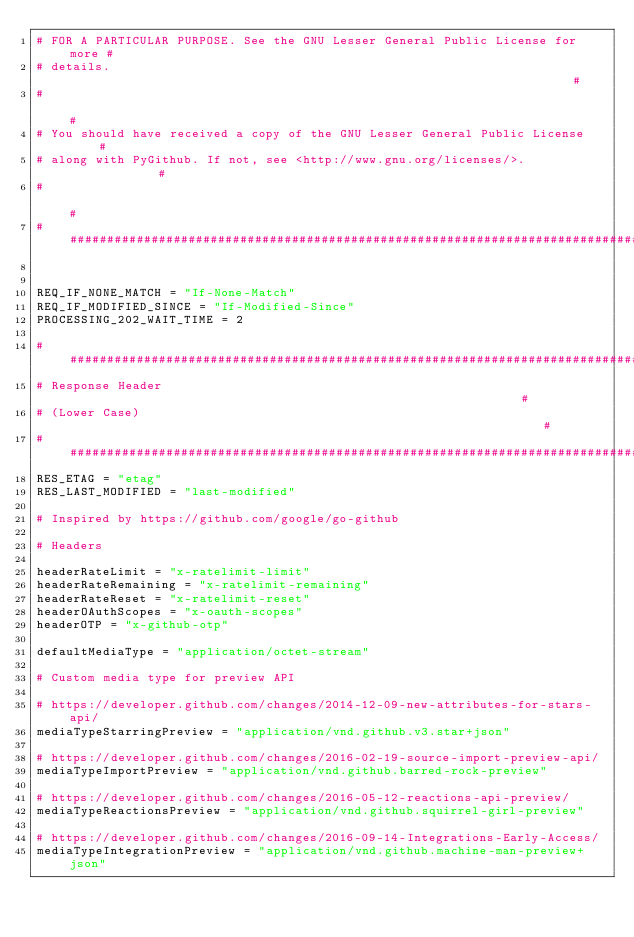Convert code to text. <code><loc_0><loc_0><loc_500><loc_500><_Python_># FOR A PARTICULAR PURPOSE. See the GNU Lesser General Public License for more #
# details.                                                                     #
#                                                                              #
# You should have received a copy of the GNU Lesser General Public License     #
# along with PyGithub. If not, see <http://www.gnu.org/licenses/>.             #
#                                                                              #
################################################################################


REQ_IF_NONE_MATCH = "If-None-Match"
REQ_IF_MODIFIED_SINCE = "If-Modified-Since"
PROCESSING_202_WAIT_TIME = 2

# ##############################################################################
# Response Header                                                              #
# (Lower Case)                                                                 #
# ##############################################################################
RES_ETAG = "etag"
RES_LAST_MODIFIED = "last-modified"

# Inspired by https://github.com/google/go-github

# Headers

headerRateLimit = "x-ratelimit-limit"
headerRateRemaining = "x-ratelimit-remaining"
headerRateReset = "x-ratelimit-reset"
headerOAuthScopes = "x-oauth-scopes"
headerOTP = "x-github-otp"

defaultMediaType = "application/octet-stream"

# Custom media type for preview API

# https://developer.github.com/changes/2014-12-09-new-attributes-for-stars-api/
mediaTypeStarringPreview = "application/vnd.github.v3.star+json"

# https://developer.github.com/changes/2016-02-19-source-import-preview-api/
mediaTypeImportPreview = "application/vnd.github.barred-rock-preview"

# https://developer.github.com/changes/2016-05-12-reactions-api-preview/
mediaTypeReactionsPreview = "application/vnd.github.squirrel-girl-preview"

# https://developer.github.com/changes/2016-09-14-Integrations-Early-Access/
mediaTypeIntegrationPreview = "application/vnd.github.machine-man-preview+json"
</code> 